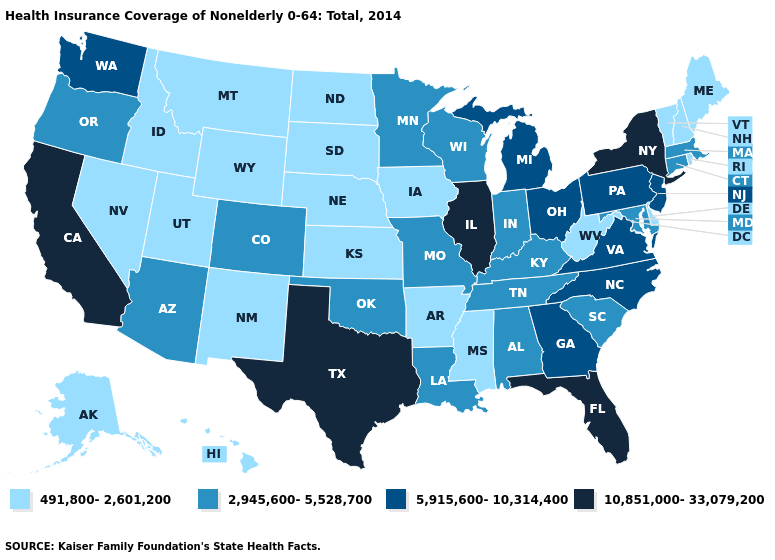What is the value of Illinois?
Write a very short answer. 10,851,000-33,079,200. Name the states that have a value in the range 491,800-2,601,200?
Write a very short answer. Alaska, Arkansas, Delaware, Hawaii, Idaho, Iowa, Kansas, Maine, Mississippi, Montana, Nebraska, Nevada, New Hampshire, New Mexico, North Dakota, Rhode Island, South Dakota, Utah, Vermont, West Virginia, Wyoming. Name the states that have a value in the range 2,945,600-5,528,700?
Be succinct. Alabama, Arizona, Colorado, Connecticut, Indiana, Kentucky, Louisiana, Maryland, Massachusetts, Minnesota, Missouri, Oklahoma, Oregon, South Carolina, Tennessee, Wisconsin. Is the legend a continuous bar?
Quick response, please. No. What is the value of Michigan?
Give a very brief answer. 5,915,600-10,314,400. Among the states that border Wisconsin , which have the lowest value?
Keep it brief. Iowa. What is the lowest value in states that border Iowa?
Quick response, please. 491,800-2,601,200. What is the value of Maryland?
Quick response, please. 2,945,600-5,528,700. Does Vermont have the lowest value in the USA?
Concise answer only. Yes. Does the map have missing data?
Give a very brief answer. No. Which states hav the highest value in the MidWest?
Answer briefly. Illinois. Name the states that have a value in the range 5,915,600-10,314,400?
Keep it brief. Georgia, Michigan, New Jersey, North Carolina, Ohio, Pennsylvania, Virginia, Washington. Among the states that border Iowa , does Minnesota have the lowest value?
Quick response, please. No. What is the value of Nebraska?
Give a very brief answer. 491,800-2,601,200. Does Maine have a lower value than Alaska?
Give a very brief answer. No. 